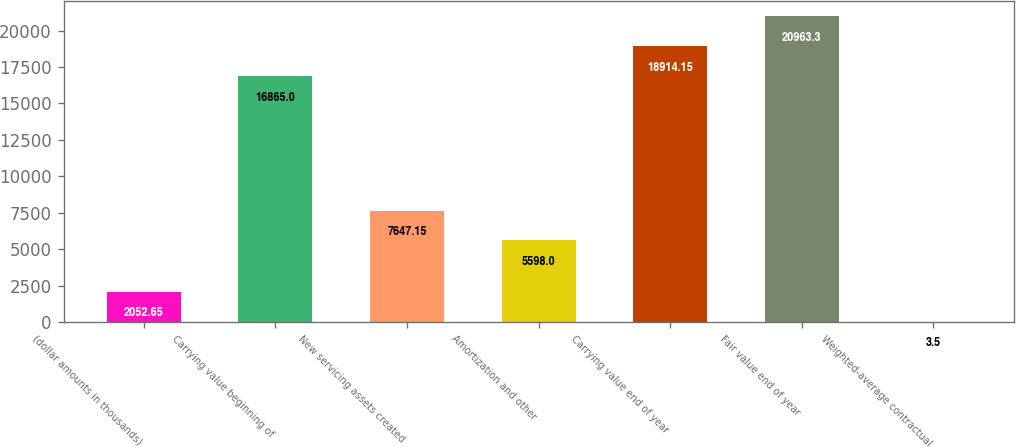Convert chart to OTSL. <chart><loc_0><loc_0><loc_500><loc_500><bar_chart><fcel>(dollar amounts in thousands)<fcel>Carrying value beginning of<fcel>New servicing assets created<fcel>Amortization and other<fcel>Carrying value end of year<fcel>Fair value end of year<fcel>Weighted-average contractual<nl><fcel>2052.65<fcel>16865<fcel>7647.15<fcel>5598<fcel>18914.2<fcel>20963.3<fcel>3.5<nl></chart> 